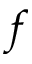<formula> <loc_0><loc_0><loc_500><loc_500>f</formula> 